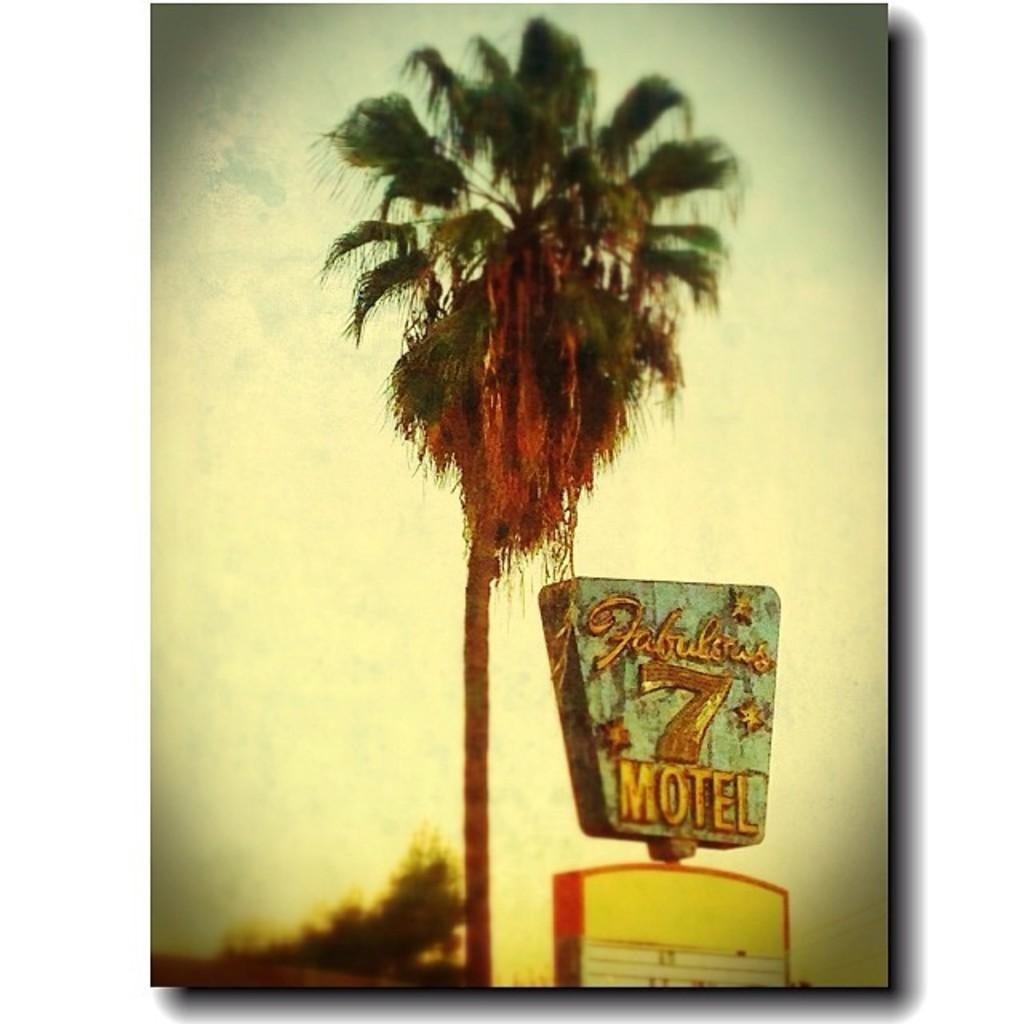What type of structures are present in the image? There are hoardings in the image. What other elements can be seen in the image besides the hoardings? There are trees in the image. What is written or displayed on the hoardings? There is text on the hoardings. Can you see any hooks in the image? There are no hooks visible in the image; the image features hoardings and trees. 